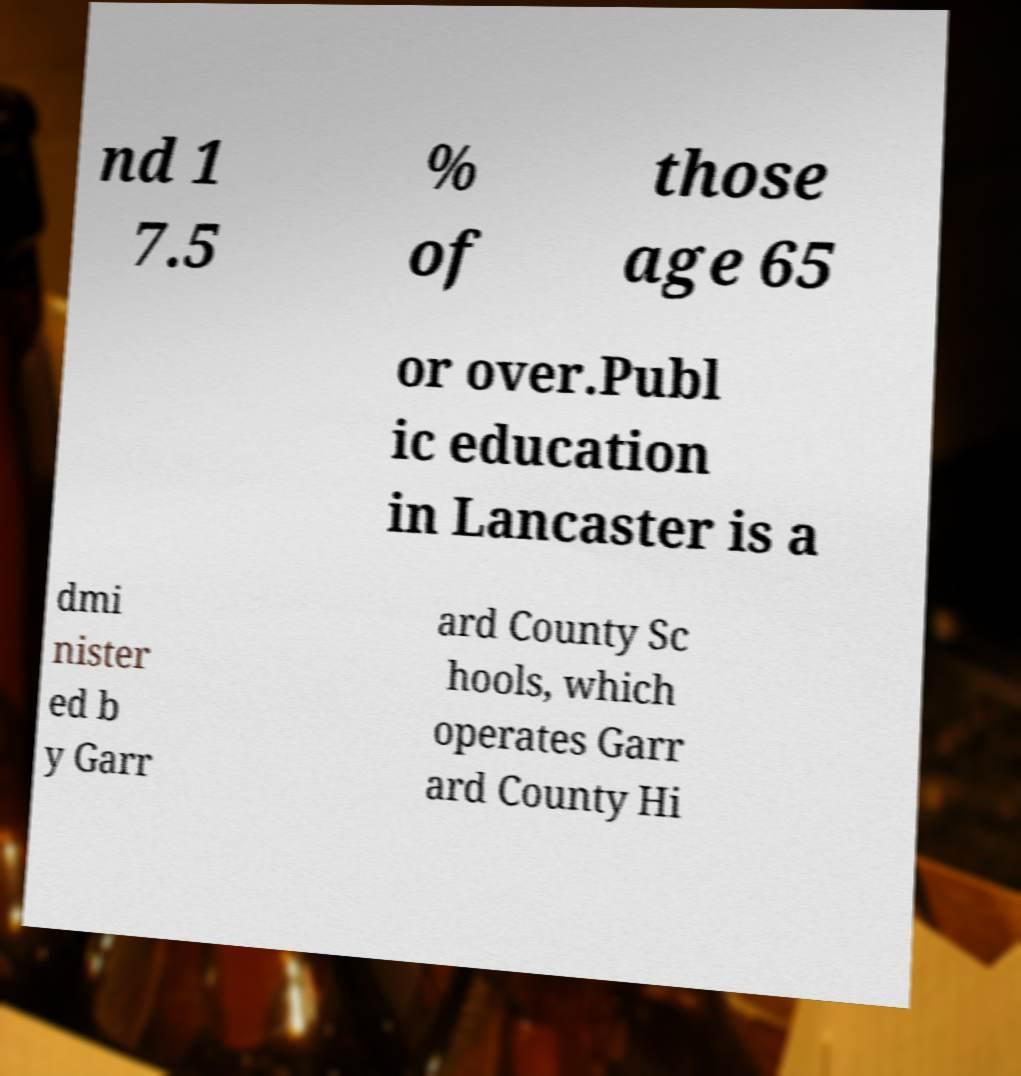Please read and relay the text visible in this image. What does it say? nd 1 7.5 % of those age 65 or over.Publ ic education in Lancaster is a dmi nister ed b y Garr ard County Sc hools, which operates Garr ard County Hi 